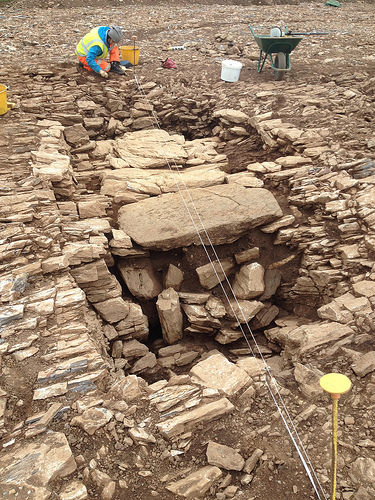<image>
Can you confirm if the wheelbarrow is behind the person? No. The wheelbarrow is not behind the person. From this viewpoint, the wheelbarrow appears to be positioned elsewhere in the scene. Is there a pole in front of the woman? Yes. The pole is positioned in front of the woman, appearing closer to the camera viewpoint. 